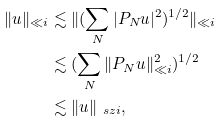<formula> <loc_0><loc_0><loc_500><loc_500>\| u \| _ { \ll i } & \lesssim \| ( \sum _ { N } | P _ { N } u | ^ { 2 } ) ^ { 1 / 2 } \| _ { \ll i } \\ & \lesssim ( \sum _ { N } \| P _ { N } u \| ^ { 2 } _ { \ll i } ) ^ { 1 / 2 } \\ & \lesssim \| u \| _ { \ s z i } ,</formula> 